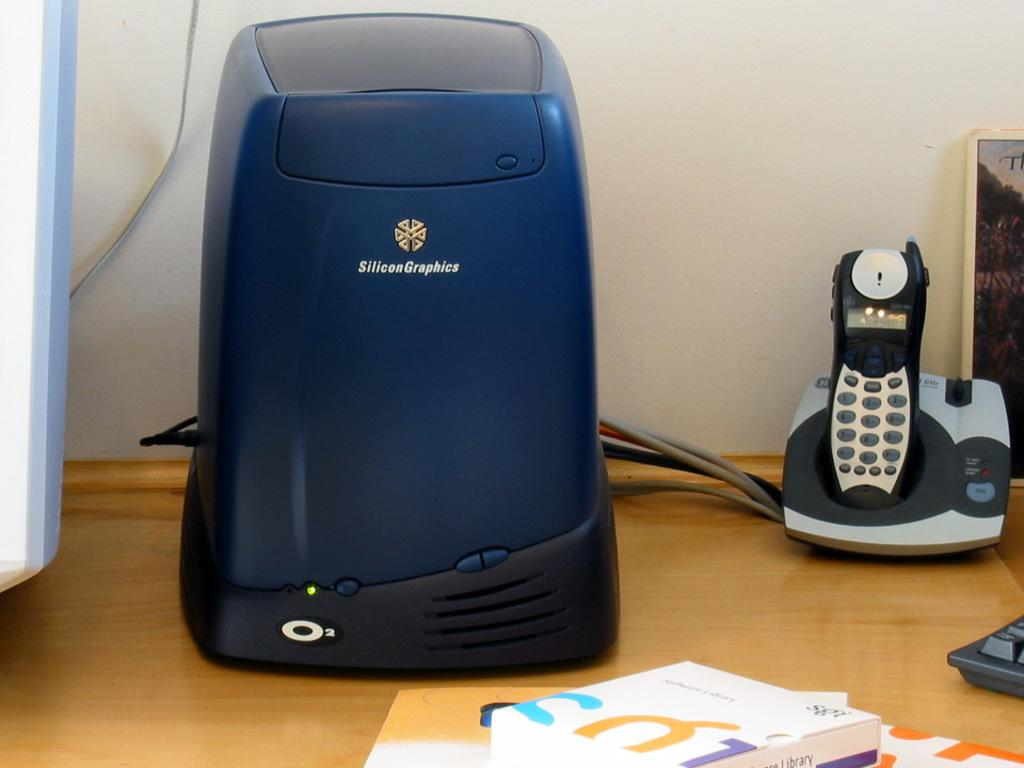<image>
Create a compact narrative representing the image presented. An electronic device was manufactured by Silicon Graphics. 